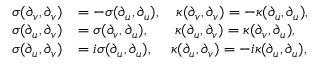Convert formula to latex. <formula><loc_0><loc_0><loc_500><loc_500>\begin{array} { r l } { \sigma ( \partial _ { v } , \partial _ { v } ) } & { = - \sigma ( \partial _ { u } , \partial _ { u } ) , \quad \kappa ( \partial _ { v } , \partial _ { v } ) = - \kappa ( \partial _ { u } , \partial _ { u } ) , } \\ { \sigma ( \partial _ { u } , \partial _ { v } ) } & { = \sigma ( \partial _ { v } , \partial _ { u } ) , \quad \, \kappa ( \partial _ { u } , \partial _ { v } ) = \kappa ( \partial _ { v } , \partial _ { u } ) , } \\ { \sigma ( \partial _ { u } , \partial _ { v } ) } & { = i \sigma ( \partial _ { u } , \partial _ { u } ) , \quad \, \kappa ( \partial _ { u } , \partial _ { v } ) = - i \kappa ( \partial _ { u } , \partial _ { u } ) , } \end{array}</formula> 